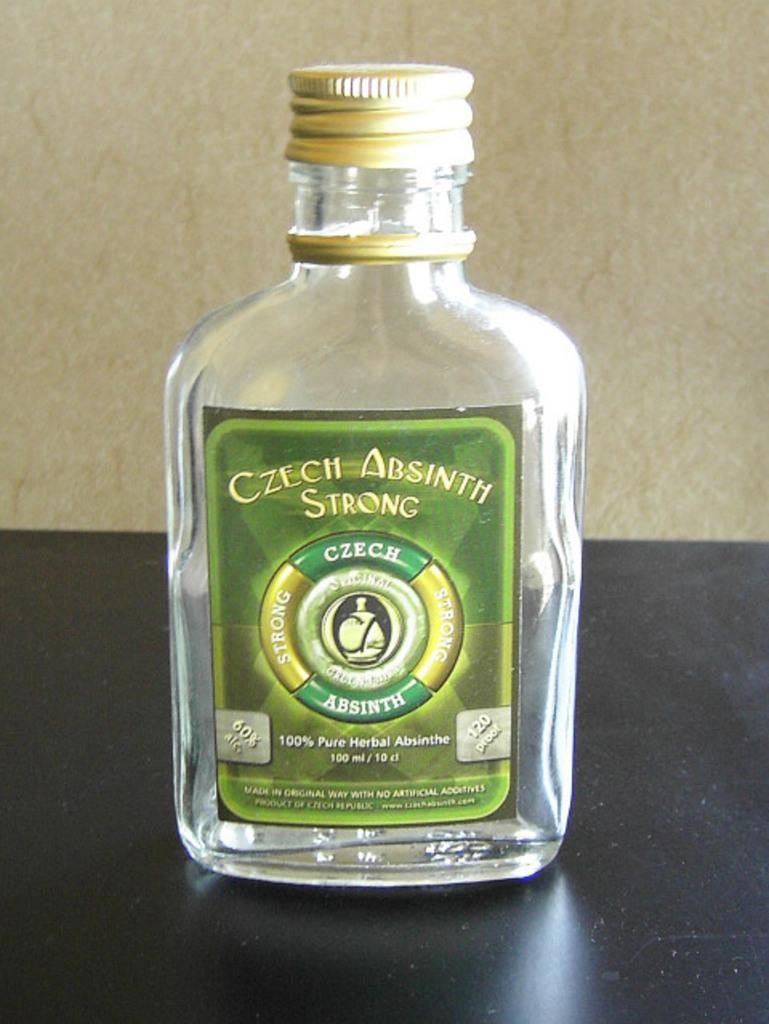<image>
Give a short and clear explanation of the subsequent image. A bottle of Czech Absinth is on a black countertop. 